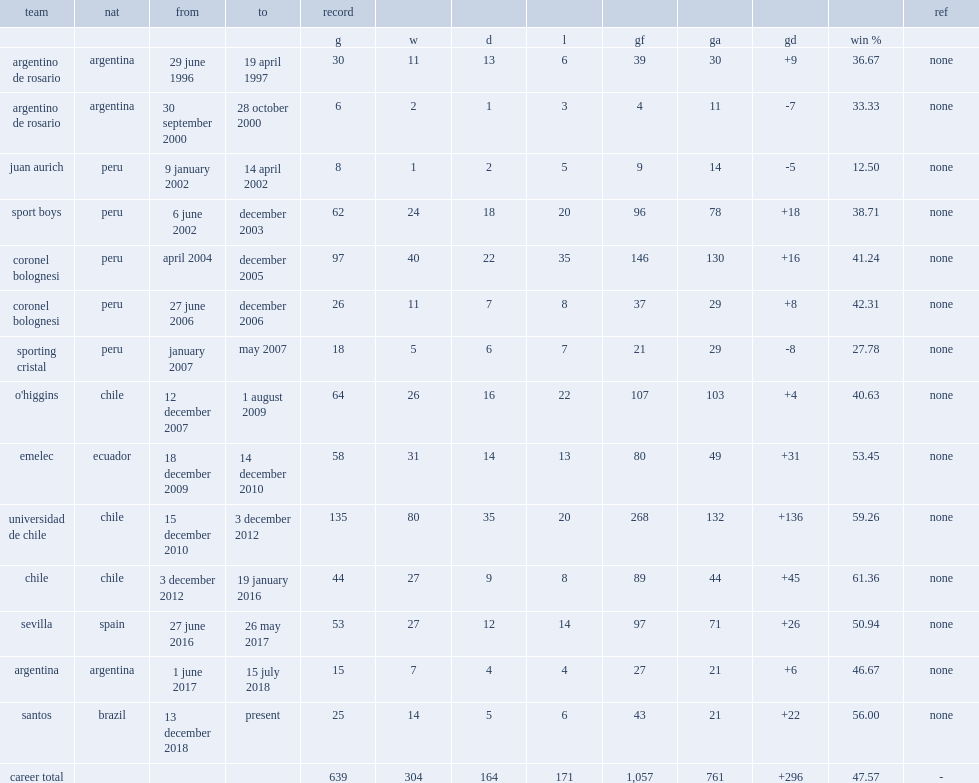Which club did sampaoli play for on 12 december 2007? O'higgins. 